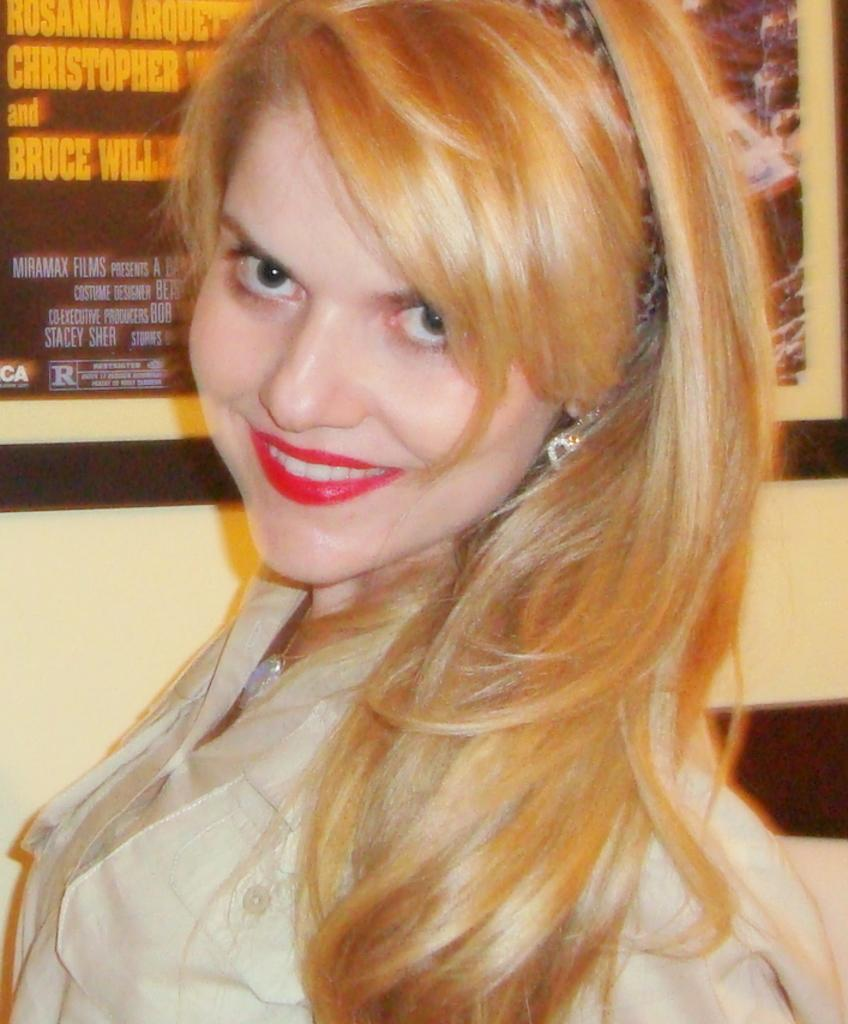Who is the main subject in the image? There is a woman in the image. What is the woman wearing? The woman is wearing a cream shirt. What can be seen in the background of the image? There is a wall with frames in the background of the image. What type of statement is the woman making in the image? There is no indication in the image that the woman is making a statement, so it cannot be determined from the picture. 